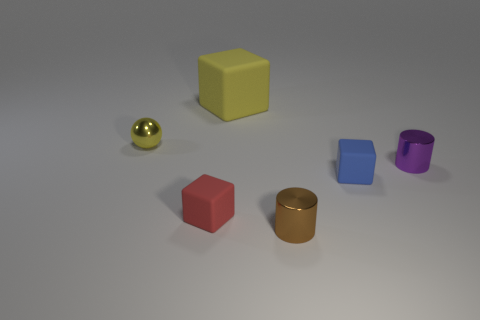Add 3 small objects. How many objects exist? 9 Subtract all spheres. How many objects are left? 5 Add 6 tiny metal things. How many tiny metal things are left? 9 Add 5 tiny gray objects. How many tiny gray objects exist? 5 Subtract 1 red cubes. How many objects are left? 5 Subtract all big brown spheres. Subtract all tiny cylinders. How many objects are left? 4 